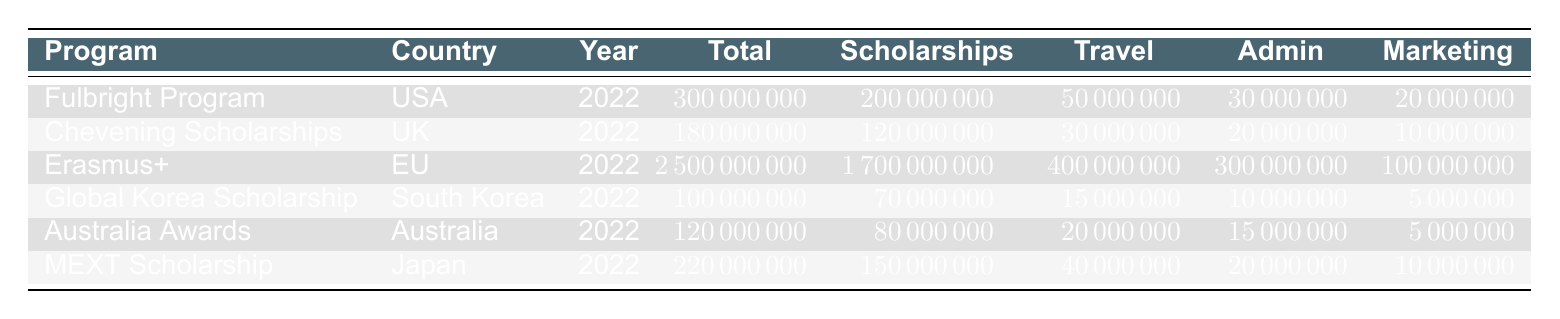What is the total expenditure for the Erasmus+ program? The total expenditure for the Erasmus+ program is listed directly in the table under the "Total" column for that program. It shows 2500000000.
Answer: 2500000000 How much was spent on scholarships by the Fulbright Program? The Fulbright Program's expenditure on scholarships can be found in the "Scholarships" column for that specific program, which shows 200000000.
Answer: 200000000 Which program had the highest administrative costs, and what was the amount? To find the program with the highest administrative costs, we look at the "Admin" column and compare the values: Fulbright Program (30000000), Chevening Scholarships (20000000), Erasmus+ (300000000), Global Korea Scholarship (10000000), Australia Awards (15000000), and MEXT Scholarship (20000000). The Erasmus+ program has the highest administrative costs of 300000000.
Answer: Erasmus+, 300000000 What is the combined total expenditure on travel costs for the Australia Awards and the Global Korea Scholarship? To find the total expenditure on travel costs for these two programs, we add the values from the "Travel" column: Australia Awards (20000000) + Global Korea Scholarship (15000000) = 35000000.
Answer: 35000000 Did the UK spend more on marketing and outreach than Japan for their cultural exchange programs? We can compare the values in the "Marketing" column for both programs: UK (Chevening Scholarships) spent 10000000, while Japan (MEXT Scholarship) spent 10000000. Since both values are the same, the UK did not spend more.
Answer: No 